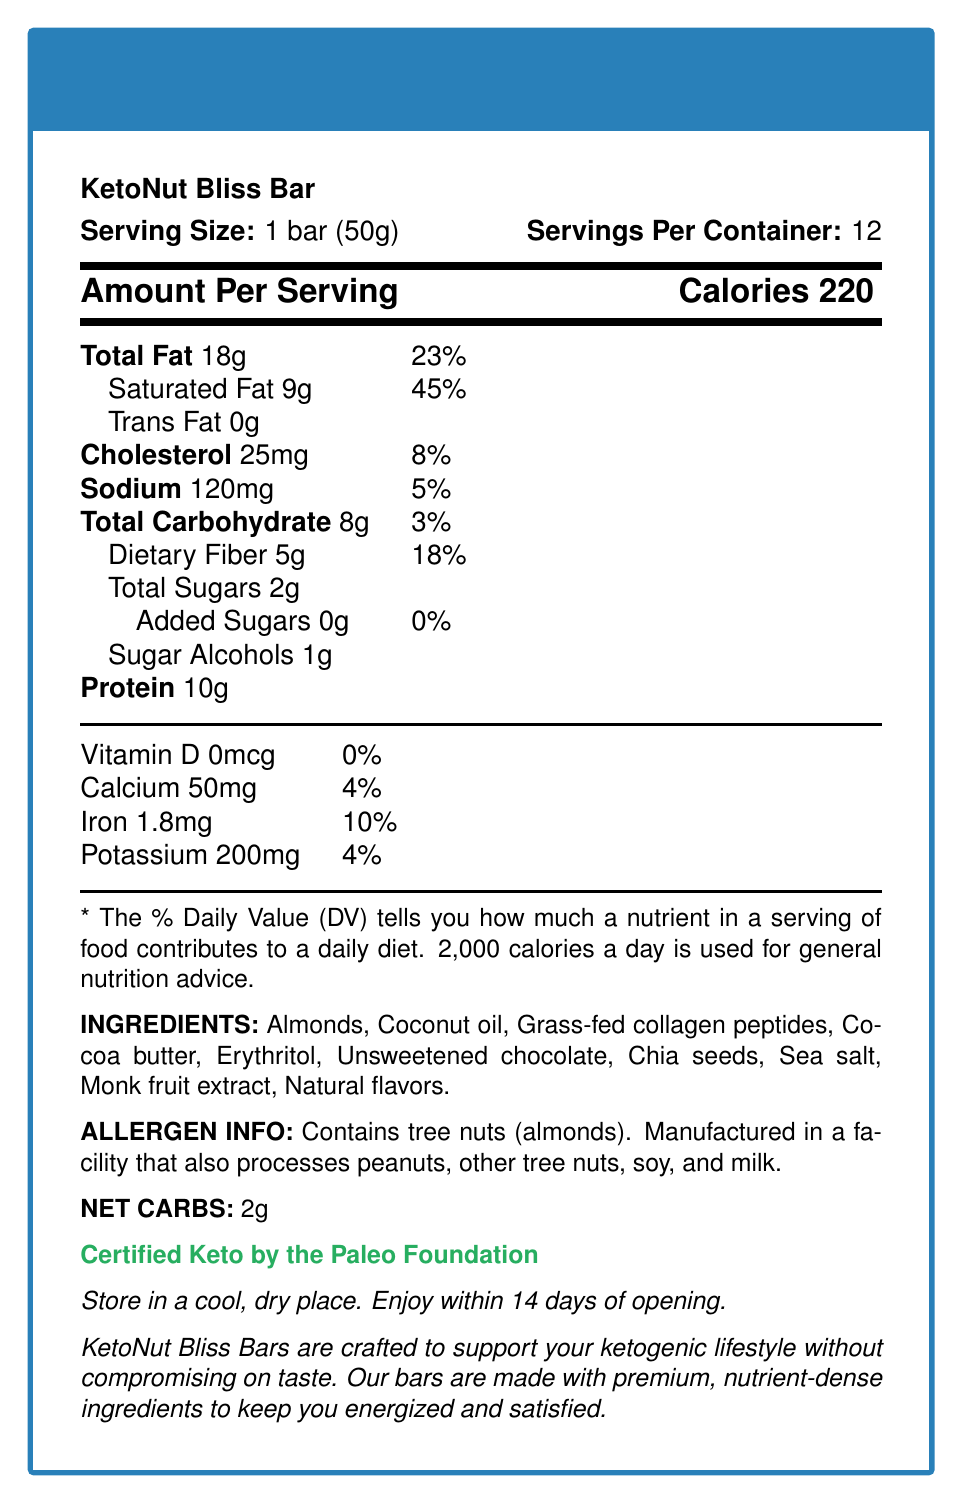What is the serving size of the KetoNut Bliss Bar? The document states the serving size as "1 bar (50g)."
Answer: 1 bar (50g) How many servings are in each container? The label indicates there are 12 servings per container.
Answer: 12 How many calories does one KetoNut Bliss Bar provide? The label under "Amount Per Serving" states there are 220 calories in one bar.
Answer: 220 calories What percentage of daily value is provided by the total fat content in one bar? The label shows that the total fat is 18g, which contributes 23% of the daily value.
Answer: 23% How much protein is in a single serving of the KetoNut Bliss Bar? The label lists the protein content as 10g per serving.
Answer: 10g How much dietary fiber is in each KetoNut Bliss Bar? The label specifies that there are 5g of dietary fiber per bar.
Answer: 5g Which ingredient is used as a sweetener in the KetoNut Bliss Bar? A. Cane Sugar B. Monk Fruit Extract C. Stevia The list of ingredients includes monk fruit extract, which is commonly used as a sweetener.
Answer: B. Monk Fruit Extract What is the net carb content per bar? 1. 2g 2. 5g 3. 8g 4. 18g The label clearly mentions that the net carbs are 2g.
Answer: 1. 2g Does the KetoNut Bliss Bar contain any artificial flavors? The ingredients list does not mention any artificial flavors, only natural flavors.
Answer: No Is the KetoNut Bliss Bar certified keto by any organization? The label states that it is "Certified Keto by the Paleo Foundation."
Answer: Yes Summarize the main idea of the document in one sentence. The document outlines comprehensive details including serving size, nutritional content, ingredient list, allergens, and keto certification, summarizing the KetoNut Bliss Bar's suitability for keto dieters.
Answer: The document provides nutritional information for the KetoNut Bliss Bar, a low-carb, high-fat snack with ingredients and certifications tailored for the ketogenic diet. How much calcium does one bar contain? The label under the vitamins and minerals section lists calcium at 50mg.
Answer: 50mg Can this document tell me where the ingredients were sourced from? The document does not provide information regarding the sourcing of the ingredients.
Answer: Cannot be determined What is the primary fat source in the KetoNut Bliss Bar? A. Olive Oil B. Coconut oil C. Butter D. Palm oil Coconut oil is listed as one of the primary ingredients.
Answer: B. Coconut oil Is the KetoNut Bliss Bar suitable for people with nut allergies? The allergen information clearly states that the product contains tree nuts (almonds) and is manufactured in a facility that processes other tree nuts.
Answer: No 